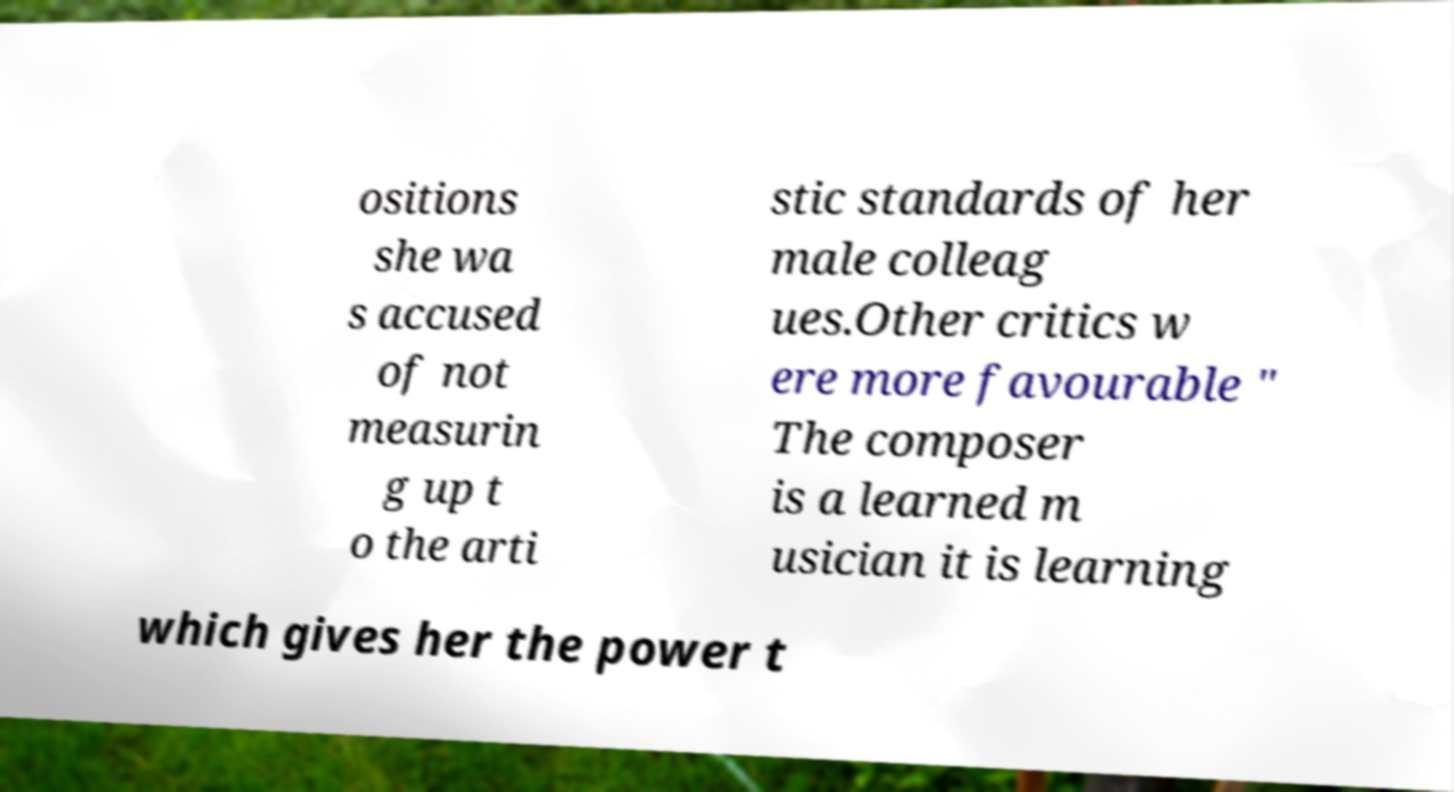I need the written content from this picture converted into text. Can you do that? ositions she wa s accused of not measurin g up t o the arti stic standards of her male colleag ues.Other critics w ere more favourable " The composer is a learned m usician it is learning which gives her the power t 